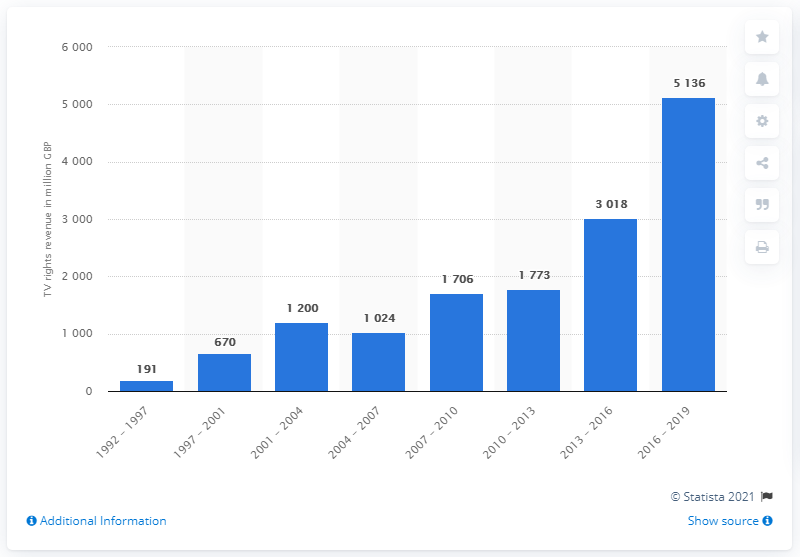Specify some key components in this picture. The Premier League generated approximately 3018 million pounds in revenue from its marketing of TV broadcasting rights from 2013 to 2016. 